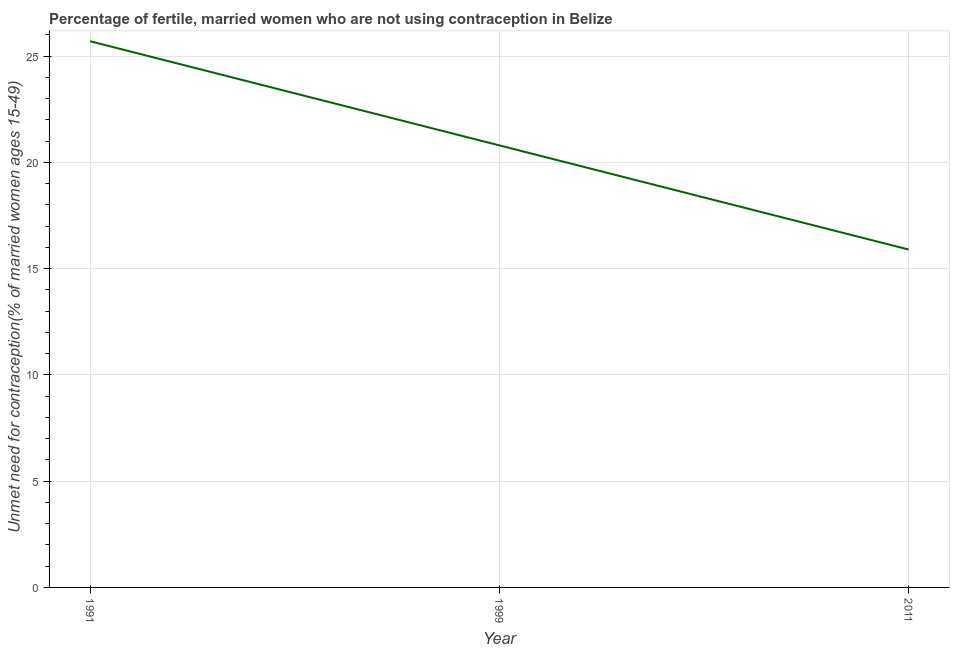What is the number of married women who are not using contraception in 1991?
Give a very brief answer. 25.7. Across all years, what is the maximum number of married women who are not using contraception?
Offer a terse response. 25.7. Across all years, what is the minimum number of married women who are not using contraception?
Offer a terse response. 15.9. In which year was the number of married women who are not using contraception maximum?
Provide a short and direct response. 1991. In which year was the number of married women who are not using contraception minimum?
Provide a short and direct response. 2011. What is the sum of the number of married women who are not using contraception?
Ensure brevity in your answer.  62.4. What is the average number of married women who are not using contraception per year?
Your answer should be very brief. 20.8. What is the median number of married women who are not using contraception?
Your answer should be very brief. 20.8. In how many years, is the number of married women who are not using contraception greater than 24 %?
Offer a terse response. 1. What is the ratio of the number of married women who are not using contraception in 1991 to that in 2011?
Give a very brief answer. 1.62. Is the number of married women who are not using contraception in 1991 less than that in 1999?
Your answer should be very brief. No. Is the difference between the number of married women who are not using contraception in 1991 and 1999 greater than the difference between any two years?
Your answer should be very brief. No. What is the difference between the highest and the second highest number of married women who are not using contraception?
Your response must be concise. 4.9. Is the sum of the number of married women who are not using contraception in 1991 and 2011 greater than the maximum number of married women who are not using contraception across all years?
Provide a short and direct response. Yes. What is the difference between the highest and the lowest number of married women who are not using contraception?
Give a very brief answer. 9.8. In how many years, is the number of married women who are not using contraception greater than the average number of married women who are not using contraception taken over all years?
Your answer should be very brief. 1. Does the number of married women who are not using contraception monotonically increase over the years?
Provide a short and direct response. No. How many lines are there?
Provide a succinct answer. 1. Does the graph contain any zero values?
Ensure brevity in your answer.  No. What is the title of the graph?
Your answer should be compact. Percentage of fertile, married women who are not using contraception in Belize. What is the label or title of the Y-axis?
Provide a short and direct response.  Unmet need for contraception(% of married women ages 15-49). What is the  Unmet need for contraception(% of married women ages 15-49) of 1991?
Your answer should be very brief. 25.7. What is the  Unmet need for contraception(% of married women ages 15-49) of 1999?
Ensure brevity in your answer.  20.8. What is the difference between the  Unmet need for contraception(% of married women ages 15-49) in 1991 and 1999?
Ensure brevity in your answer.  4.9. What is the ratio of the  Unmet need for contraception(% of married women ages 15-49) in 1991 to that in 1999?
Your answer should be very brief. 1.24. What is the ratio of the  Unmet need for contraception(% of married women ages 15-49) in 1991 to that in 2011?
Keep it short and to the point. 1.62. What is the ratio of the  Unmet need for contraception(% of married women ages 15-49) in 1999 to that in 2011?
Keep it short and to the point. 1.31. 